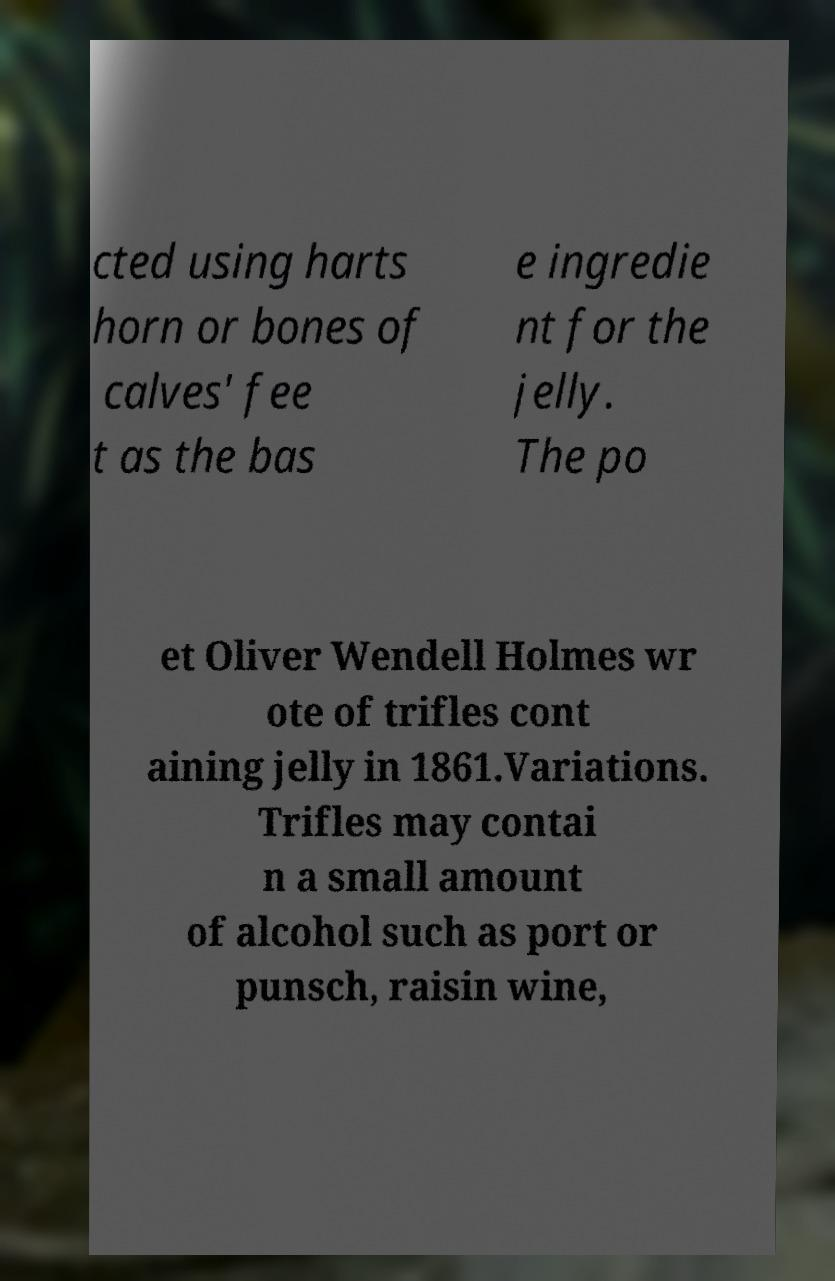Please read and relay the text visible in this image. What does it say? cted using harts horn or bones of calves' fee t as the bas e ingredie nt for the jelly. The po et Oliver Wendell Holmes wr ote of trifles cont aining jelly in 1861.Variations. Trifles may contai n a small amount of alcohol such as port or punsch, raisin wine, 